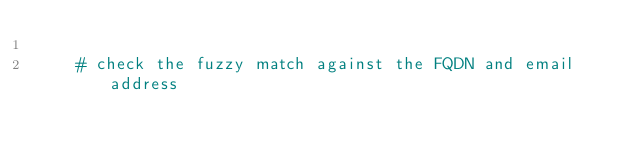<code> <loc_0><loc_0><loc_500><loc_500><_Python_>
    # check the fuzzy match against the FQDN and email address</code> 